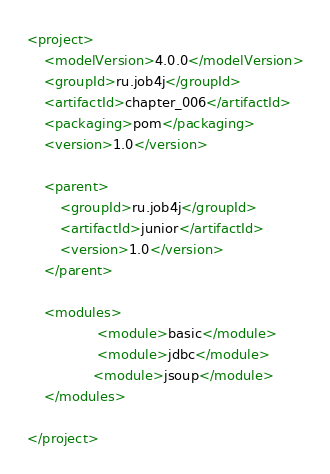<code> <loc_0><loc_0><loc_500><loc_500><_XML_><project>
	<modelVersion>4.0.0</modelVersion>
	<groupId>ru.job4j</groupId>
	<artifactId>chapter_006</artifactId>
	<packaging>pom</packaging>
	<version>1.0</version>
	
	<parent>
		<groupId>ru.job4j</groupId>
		<artifactId>junior</artifactId>
		<version>1.0</version>
	</parent>

	<modules>
                 <module>basic</module>
                 <module>jdbc</module>
				<module>jsoup</module>
	</modules>

</project></code> 